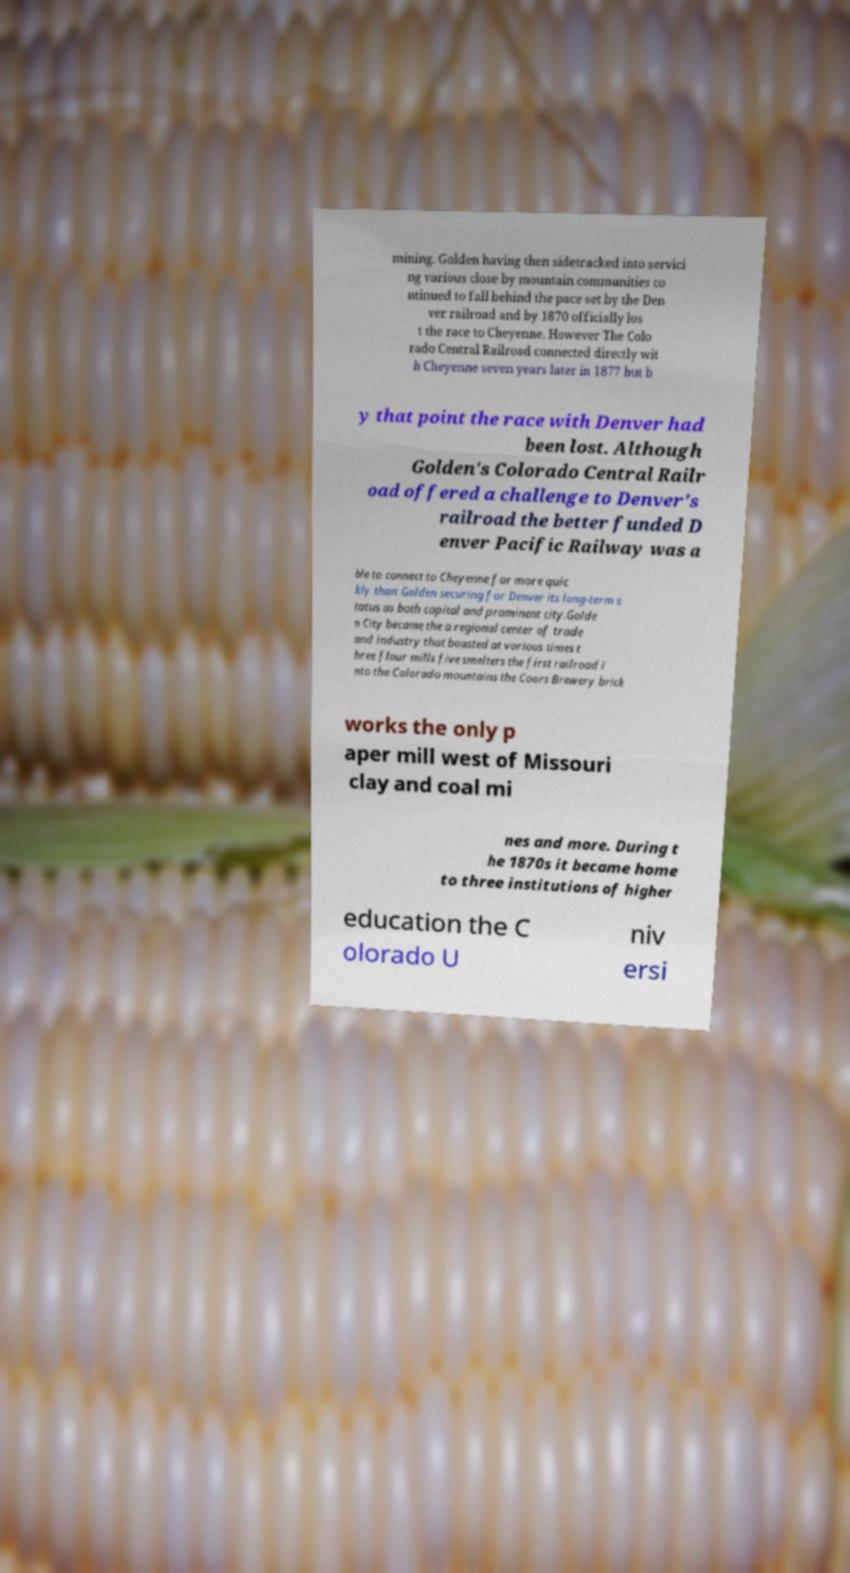Could you assist in decoding the text presented in this image and type it out clearly? mining. Golden having then sidetracked into servici ng various close by mountain communities co ntinued to fall behind the pace set by the Den ver railroad and by 1870 officially los t the race to Cheyenne. However The Colo rado Central Railroad connected directly wit h Cheyenne seven years later in 1877 but b y that point the race with Denver had been lost. Although Golden's Colorado Central Railr oad offered a challenge to Denver's railroad the better funded D enver Pacific Railway was a ble to connect to Cheyenne far more quic kly than Golden securing for Denver its long-term s tatus as both capital and prominent city.Golde n City became the a regional center of trade and industry that boasted at various times t hree flour mills five smelters the first railroad i nto the Colorado mountains the Coors Brewery brick works the only p aper mill west of Missouri clay and coal mi nes and more. During t he 1870s it became home to three institutions of higher education the C olorado U niv ersi 